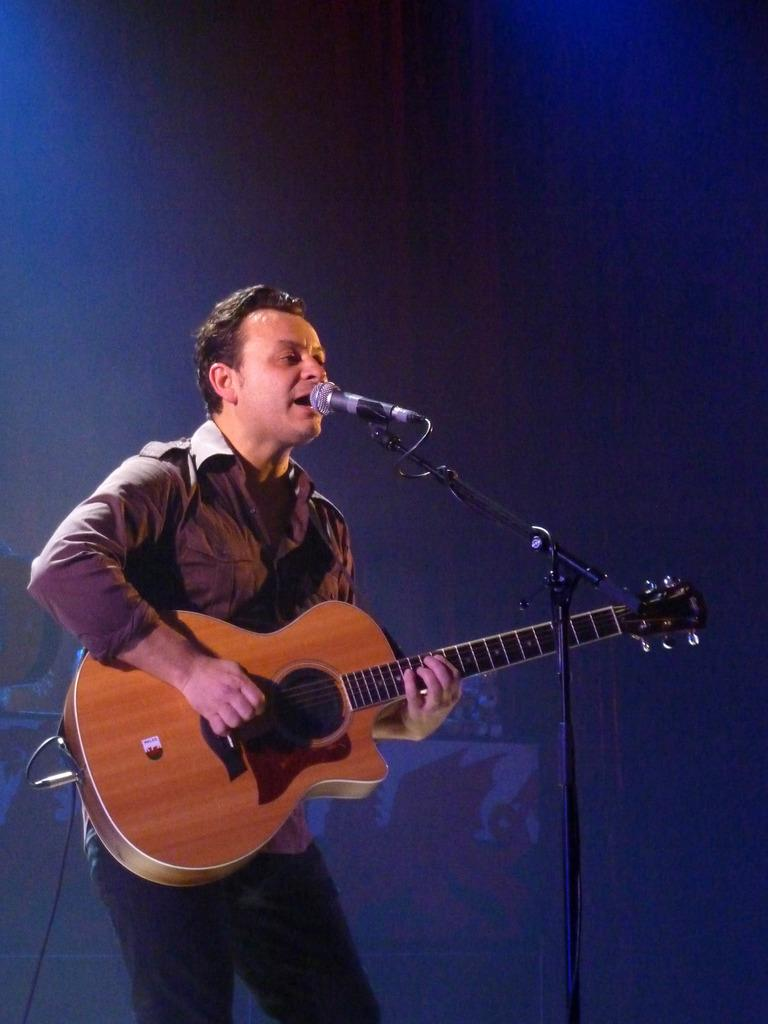What is the main subject of the image? The main subject of the image is a man. What is the man doing in the image? The man is standing in front of a microphone and playing a guitar. What type of stitch is the man using to play the guitar in the image? The man is not using any stitch to play the guitar; he is using his hands to strum the strings. What subject is the man teaching in the image? There is no indication in the image that the man is teaching any subject. --- 